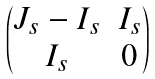Convert formula to latex. <formula><loc_0><loc_0><loc_500><loc_500>\begin{pmatrix} J _ { s } - I _ { s } & I _ { s } \\ I _ { s } & 0 \end{pmatrix}</formula> 